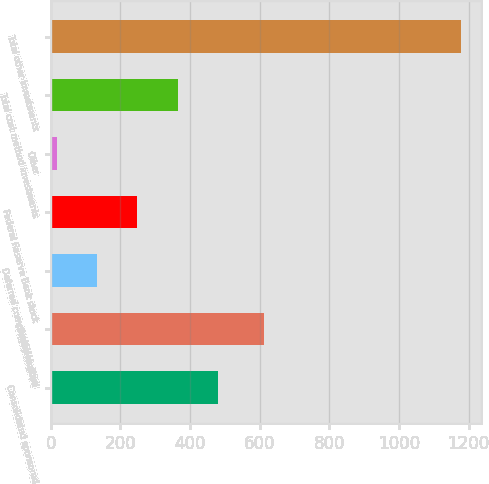Convert chart to OTSL. <chart><loc_0><loc_0><loc_500><loc_500><bar_chart><fcel>Consolidated sponsored<fcel>Equity method<fcel>Deferred compensation plan<fcel>Federal Reserve Bank stock<fcel>Other<fcel>Total cost method investments<fcel>Total other investments<nl><fcel>481<fcel>613<fcel>133<fcel>249<fcel>17<fcel>365<fcel>1177<nl></chart> 